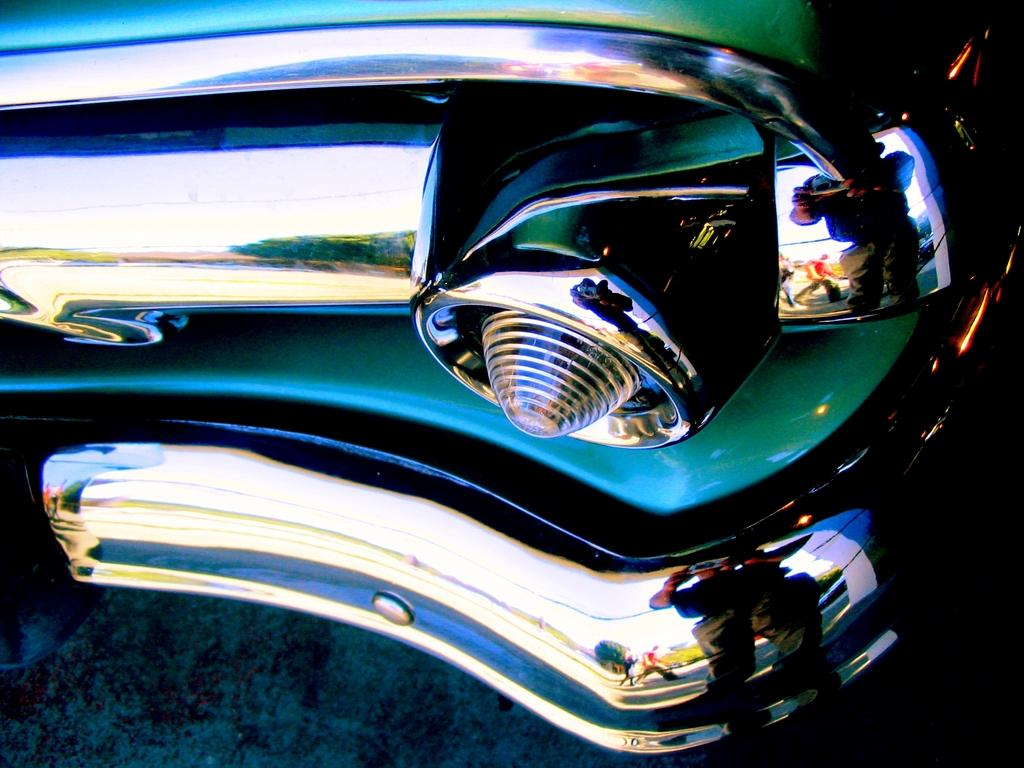What type of vehicle is partially visible in the image? There is a part of a vehicle in the image, but the specific type cannot be determined from the provided facts. Can you describe the reflection in the image? There is a reflection of three persons in the image. What type of natural environment is visible in the image? Trees are visible in the image, indicating a natural environment. What is visible in the background of the image? The sky is visible in the image. What type of tray is being used by the team in the image? There is no tray or team present in the image. What scene is depicted in the image? The image does not depict a specific scene; it shows a part of a vehicle, a reflection of three persons, trees, and the sky. 